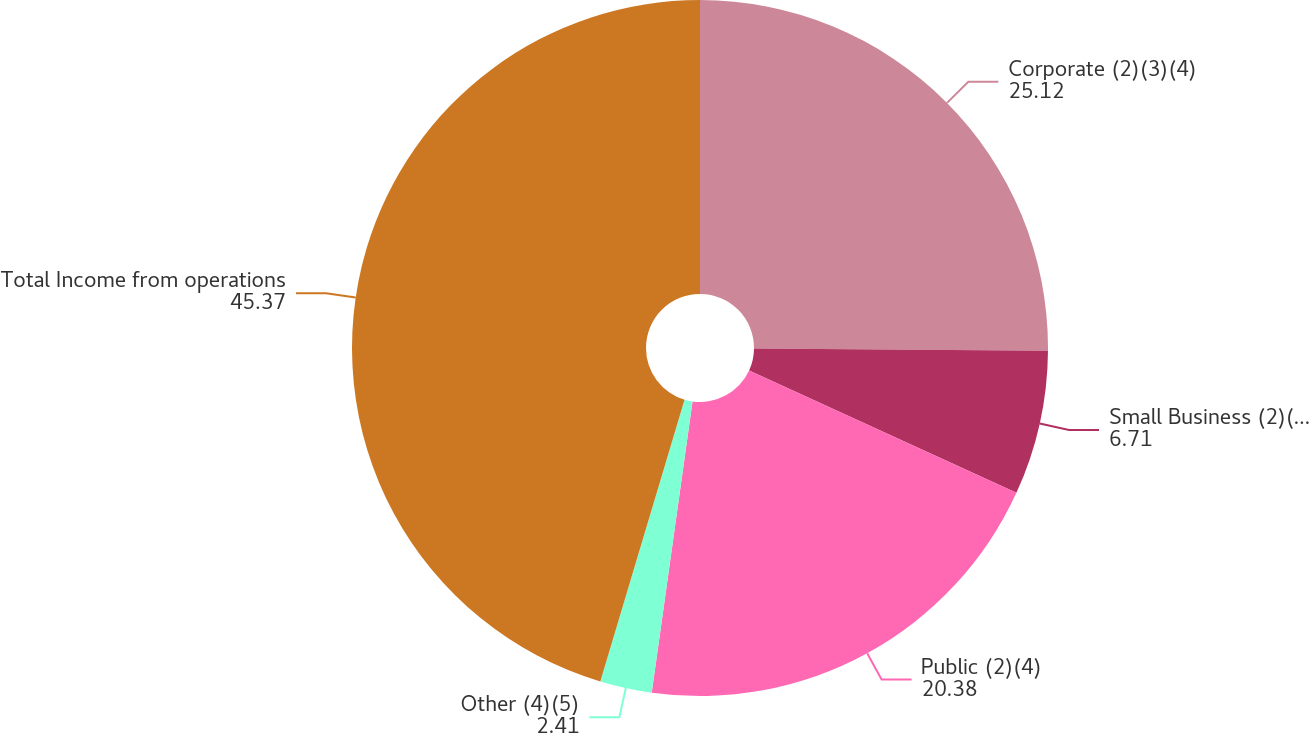Convert chart. <chart><loc_0><loc_0><loc_500><loc_500><pie_chart><fcel>Corporate (2)(3)(4)<fcel>Small Business (2)(3)(4)<fcel>Public (2)(4)<fcel>Other (4)(5)<fcel>Total Income from operations<nl><fcel>25.12%<fcel>6.71%<fcel>20.38%<fcel>2.41%<fcel>45.37%<nl></chart> 